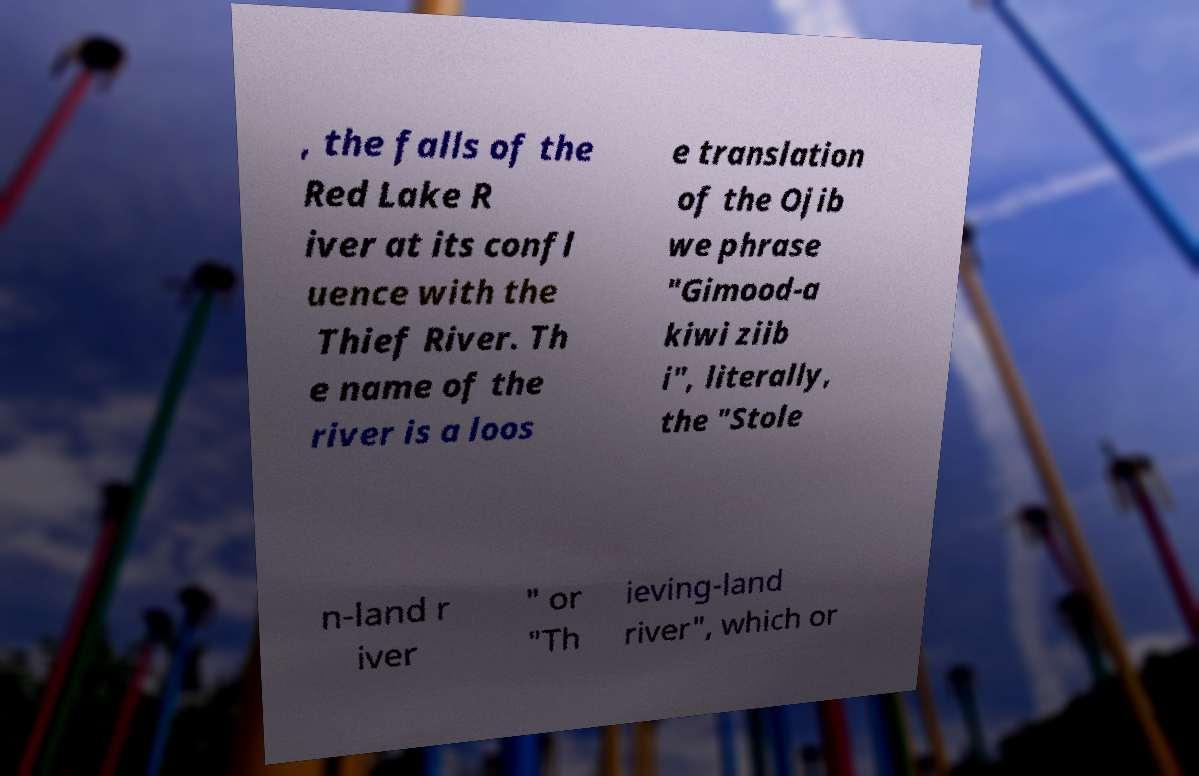There's text embedded in this image that I need extracted. Can you transcribe it verbatim? , the falls of the Red Lake R iver at its confl uence with the Thief River. Th e name of the river is a loos e translation of the Ojib we phrase "Gimood-a kiwi ziib i", literally, the "Stole n-land r iver " or "Th ieving-land river", which or 